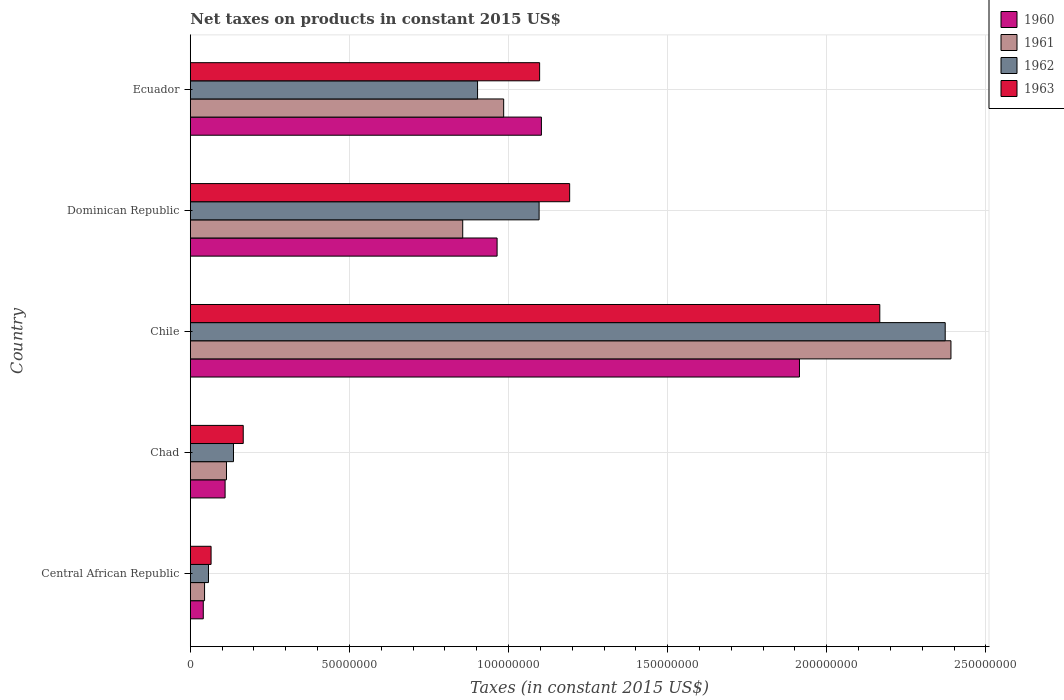How many groups of bars are there?
Provide a short and direct response. 5. How many bars are there on the 4th tick from the top?
Your answer should be compact. 4. How many bars are there on the 3rd tick from the bottom?
Keep it short and to the point. 4. What is the label of the 2nd group of bars from the top?
Provide a short and direct response. Dominican Republic. What is the net taxes on products in 1963 in Central African Republic?
Keep it short and to the point. 6.53e+06. Across all countries, what is the maximum net taxes on products in 1962?
Provide a short and direct response. 2.37e+08. Across all countries, what is the minimum net taxes on products in 1963?
Provide a short and direct response. 6.53e+06. In which country was the net taxes on products in 1962 minimum?
Your response must be concise. Central African Republic. What is the total net taxes on products in 1961 in the graph?
Offer a very short reply. 4.39e+08. What is the difference between the net taxes on products in 1962 in Central African Republic and that in Ecuador?
Make the answer very short. -8.45e+07. What is the difference between the net taxes on products in 1963 in Dominican Republic and the net taxes on products in 1961 in Chile?
Keep it short and to the point. -1.20e+08. What is the average net taxes on products in 1961 per country?
Ensure brevity in your answer.  8.78e+07. What is the difference between the net taxes on products in 1961 and net taxes on products in 1962 in Chile?
Provide a short and direct response. 1.81e+06. What is the ratio of the net taxes on products in 1960 in Chad to that in Dominican Republic?
Offer a terse response. 0.11. What is the difference between the highest and the second highest net taxes on products in 1961?
Give a very brief answer. 1.41e+08. What is the difference between the highest and the lowest net taxes on products in 1963?
Ensure brevity in your answer.  2.10e+08. In how many countries, is the net taxes on products in 1961 greater than the average net taxes on products in 1961 taken over all countries?
Your response must be concise. 2. Is the sum of the net taxes on products in 1962 in Chad and Dominican Republic greater than the maximum net taxes on products in 1963 across all countries?
Your answer should be compact. No. Is it the case that in every country, the sum of the net taxes on products in 1963 and net taxes on products in 1961 is greater than the sum of net taxes on products in 1960 and net taxes on products in 1962?
Make the answer very short. No. What does the 3rd bar from the bottom in Chile represents?
Your response must be concise. 1962. How many bars are there?
Your answer should be very brief. 20. How many countries are there in the graph?
Ensure brevity in your answer.  5. Does the graph contain any zero values?
Give a very brief answer. No. Does the graph contain grids?
Provide a succinct answer. Yes. Where does the legend appear in the graph?
Your response must be concise. Top right. How many legend labels are there?
Make the answer very short. 4. How are the legend labels stacked?
Your answer should be very brief. Vertical. What is the title of the graph?
Keep it short and to the point. Net taxes on products in constant 2015 US$. What is the label or title of the X-axis?
Provide a succinct answer. Taxes (in constant 2015 US$). What is the Taxes (in constant 2015 US$) in 1960 in Central African Republic?
Provide a short and direct response. 4.08e+06. What is the Taxes (in constant 2015 US$) in 1961 in Central African Republic?
Provide a short and direct response. 4.49e+06. What is the Taxes (in constant 2015 US$) of 1962 in Central African Republic?
Provide a succinct answer. 5.71e+06. What is the Taxes (in constant 2015 US$) of 1963 in Central African Republic?
Provide a short and direct response. 6.53e+06. What is the Taxes (in constant 2015 US$) of 1960 in Chad?
Your response must be concise. 1.09e+07. What is the Taxes (in constant 2015 US$) in 1961 in Chad?
Your answer should be very brief. 1.14e+07. What is the Taxes (in constant 2015 US$) of 1962 in Chad?
Make the answer very short. 1.36e+07. What is the Taxes (in constant 2015 US$) of 1963 in Chad?
Give a very brief answer. 1.66e+07. What is the Taxes (in constant 2015 US$) of 1960 in Chile?
Ensure brevity in your answer.  1.91e+08. What is the Taxes (in constant 2015 US$) of 1961 in Chile?
Make the answer very short. 2.39e+08. What is the Taxes (in constant 2015 US$) of 1962 in Chile?
Make the answer very short. 2.37e+08. What is the Taxes (in constant 2015 US$) in 1963 in Chile?
Your answer should be compact. 2.17e+08. What is the Taxes (in constant 2015 US$) of 1960 in Dominican Republic?
Give a very brief answer. 9.64e+07. What is the Taxes (in constant 2015 US$) of 1961 in Dominican Republic?
Your answer should be very brief. 8.56e+07. What is the Taxes (in constant 2015 US$) in 1962 in Dominican Republic?
Ensure brevity in your answer.  1.10e+08. What is the Taxes (in constant 2015 US$) of 1963 in Dominican Republic?
Offer a very short reply. 1.19e+08. What is the Taxes (in constant 2015 US$) of 1960 in Ecuador?
Your answer should be very brief. 1.10e+08. What is the Taxes (in constant 2015 US$) of 1961 in Ecuador?
Offer a very short reply. 9.85e+07. What is the Taxes (in constant 2015 US$) of 1962 in Ecuador?
Give a very brief answer. 9.03e+07. What is the Taxes (in constant 2015 US$) of 1963 in Ecuador?
Provide a succinct answer. 1.10e+08. Across all countries, what is the maximum Taxes (in constant 2015 US$) in 1960?
Keep it short and to the point. 1.91e+08. Across all countries, what is the maximum Taxes (in constant 2015 US$) in 1961?
Provide a short and direct response. 2.39e+08. Across all countries, what is the maximum Taxes (in constant 2015 US$) of 1962?
Make the answer very short. 2.37e+08. Across all countries, what is the maximum Taxes (in constant 2015 US$) of 1963?
Your response must be concise. 2.17e+08. Across all countries, what is the minimum Taxes (in constant 2015 US$) of 1960?
Provide a succinct answer. 4.08e+06. Across all countries, what is the minimum Taxes (in constant 2015 US$) in 1961?
Offer a terse response. 4.49e+06. Across all countries, what is the minimum Taxes (in constant 2015 US$) of 1962?
Offer a terse response. 5.71e+06. Across all countries, what is the minimum Taxes (in constant 2015 US$) of 1963?
Offer a very short reply. 6.53e+06. What is the total Taxes (in constant 2015 US$) of 1960 in the graph?
Make the answer very short. 4.13e+08. What is the total Taxes (in constant 2015 US$) in 1961 in the graph?
Offer a very short reply. 4.39e+08. What is the total Taxes (in constant 2015 US$) of 1962 in the graph?
Provide a succinct answer. 4.56e+08. What is the total Taxes (in constant 2015 US$) of 1963 in the graph?
Your response must be concise. 4.69e+08. What is the difference between the Taxes (in constant 2015 US$) in 1960 in Central African Republic and that in Chad?
Offer a very short reply. -6.86e+06. What is the difference between the Taxes (in constant 2015 US$) of 1961 in Central African Republic and that in Chad?
Offer a very short reply. -6.88e+06. What is the difference between the Taxes (in constant 2015 US$) of 1962 in Central African Republic and that in Chad?
Keep it short and to the point. -7.86e+06. What is the difference between the Taxes (in constant 2015 US$) of 1963 in Central African Republic and that in Chad?
Offer a very short reply. -1.01e+07. What is the difference between the Taxes (in constant 2015 US$) in 1960 in Central African Republic and that in Chile?
Your answer should be very brief. -1.87e+08. What is the difference between the Taxes (in constant 2015 US$) of 1961 in Central African Republic and that in Chile?
Give a very brief answer. -2.35e+08. What is the difference between the Taxes (in constant 2015 US$) in 1962 in Central African Republic and that in Chile?
Your answer should be very brief. -2.31e+08. What is the difference between the Taxes (in constant 2015 US$) of 1963 in Central African Republic and that in Chile?
Offer a terse response. -2.10e+08. What is the difference between the Taxes (in constant 2015 US$) of 1960 in Central African Republic and that in Dominican Republic?
Keep it short and to the point. -9.23e+07. What is the difference between the Taxes (in constant 2015 US$) in 1961 in Central African Republic and that in Dominican Republic?
Offer a very short reply. -8.11e+07. What is the difference between the Taxes (in constant 2015 US$) in 1962 in Central African Republic and that in Dominican Republic?
Provide a short and direct response. -1.04e+08. What is the difference between the Taxes (in constant 2015 US$) in 1963 in Central African Republic and that in Dominican Republic?
Provide a succinct answer. -1.13e+08. What is the difference between the Taxes (in constant 2015 US$) of 1960 in Central African Republic and that in Ecuador?
Provide a short and direct response. -1.06e+08. What is the difference between the Taxes (in constant 2015 US$) of 1961 in Central African Republic and that in Ecuador?
Make the answer very short. -9.40e+07. What is the difference between the Taxes (in constant 2015 US$) in 1962 in Central African Republic and that in Ecuador?
Your answer should be very brief. -8.45e+07. What is the difference between the Taxes (in constant 2015 US$) in 1963 in Central African Republic and that in Ecuador?
Provide a succinct answer. -1.03e+08. What is the difference between the Taxes (in constant 2015 US$) in 1960 in Chad and that in Chile?
Your answer should be compact. -1.80e+08. What is the difference between the Taxes (in constant 2015 US$) of 1961 in Chad and that in Chile?
Offer a terse response. -2.28e+08. What is the difference between the Taxes (in constant 2015 US$) in 1962 in Chad and that in Chile?
Your answer should be very brief. -2.24e+08. What is the difference between the Taxes (in constant 2015 US$) of 1963 in Chad and that in Chile?
Your answer should be compact. -2.00e+08. What is the difference between the Taxes (in constant 2015 US$) of 1960 in Chad and that in Dominican Republic?
Ensure brevity in your answer.  -8.55e+07. What is the difference between the Taxes (in constant 2015 US$) in 1961 in Chad and that in Dominican Republic?
Ensure brevity in your answer.  -7.42e+07. What is the difference between the Taxes (in constant 2015 US$) in 1962 in Chad and that in Dominican Republic?
Your response must be concise. -9.60e+07. What is the difference between the Taxes (in constant 2015 US$) in 1963 in Chad and that in Dominican Republic?
Make the answer very short. -1.03e+08. What is the difference between the Taxes (in constant 2015 US$) in 1960 in Chad and that in Ecuador?
Provide a short and direct response. -9.94e+07. What is the difference between the Taxes (in constant 2015 US$) of 1961 in Chad and that in Ecuador?
Make the answer very short. -8.71e+07. What is the difference between the Taxes (in constant 2015 US$) of 1962 in Chad and that in Ecuador?
Provide a short and direct response. -7.67e+07. What is the difference between the Taxes (in constant 2015 US$) in 1963 in Chad and that in Ecuador?
Make the answer very short. -9.31e+07. What is the difference between the Taxes (in constant 2015 US$) of 1960 in Chile and that in Dominican Republic?
Your answer should be very brief. 9.50e+07. What is the difference between the Taxes (in constant 2015 US$) of 1961 in Chile and that in Dominican Republic?
Make the answer very short. 1.53e+08. What is the difference between the Taxes (in constant 2015 US$) of 1962 in Chile and that in Dominican Republic?
Provide a short and direct response. 1.28e+08. What is the difference between the Taxes (in constant 2015 US$) in 1963 in Chile and that in Dominican Republic?
Offer a terse response. 9.74e+07. What is the difference between the Taxes (in constant 2015 US$) in 1960 in Chile and that in Ecuador?
Your answer should be very brief. 8.11e+07. What is the difference between the Taxes (in constant 2015 US$) of 1961 in Chile and that in Ecuador?
Offer a terse response. 1.41e+08. What is the difference between the Taxes (in constant 2015 US$) of 1962 in Chile and that in Ecuador?
Provide a short and direct response. 1.47e+08. What is the difference between the Taxes (in constant 2015 US$) of 1963 in Chile and that in Ecuador?
Your answer should be very brief. 1.07e+08. What is the difference between the Taxes (in constant 2015 US$) in 1960 in Dominican Republic and that in Ecuador?
Provide a succinct answer. -1.39e+07. What is the difference between the Taxes (in constant 2015 US$) in 1961 in Dominican Republic and that in Ecuador?
Offer a terse response. -1.29e+07. What is the difference between the Taxes (in constant 2015 US$) of 1962 in Dominican Republic and that in Ecuador?
Make the answer very short. 1.93e+07. What is the difference between the Taxes (in constant 2015 US$) in 1963 in Dominican Republic and that in Ecuador?
Keep it short and to the point. 9.44e+06. What is the difference between the Taxes (in constant 2015 US$) in 1960 in Central African Republic and the Taxes (in constant 2015 US$) in 1961 in Chad?
Provide a succinct answer. -7.29e+06. What is the difference between the Taxes (in constant 2015 US$) in 1960 in Central African Republic and the Taxes (in constant 2015 US$) in 1962 in Chad?
Provide a succinct answer. -9.49e+06. What is the difference between the Taxes (in constant 2015 US$) in 1960 in Central African Republic and the Taxes (in constant 2015 US$) in 1963 in Chad?
Provide a succinct answer. -1.26e+07. What is the difference between the Taxes (in constant 2015 US$) in 1961 in Central African Republic and the Taxes (in constant 2015 US$) in 1962 in Chad?
Provide a succinct answer. -9.08e+06. What is the difference between the Taxes (in constant 2015 US$) in 1961 in Central African Republic and the Taxes (in constant 2015 US$) in 1963 in Chad?
Provide a short and direct response. -1.21e+07. What is the difference between the Taxes (in constant 2015 US$) in 1962 in Central African Republic and the Taxes (in constant 2015 US$) in 1963 in Chad?
Offer a very short reply. -1.09e+07. What is the difference between the Taxes (in constant 2015 US$) of 1960 in Central African Republic and the Taxes (in constant 2015 US$) of 1961 in Chile?
Your answer should be compact. -2.35e+08. What is the difference between the Taxes (in constant 2015 US$) of 1960 in Central African Republic and the Taxes (in constant 2015 US$) of 1962 in Chile?
Your answer should be compact. -2.33e+08. What is the difference between the Taxes (in constant 2015 US$) in 1960 in Central African Republic and the Taxes (in constant 2015 US$) in 1963 in Chile?
Ensure brevity in your answer.  -2.13e+08. What is the difference between the Taxes (in constant 2015 US$) in 1961 in Central African Republic and the Taxes (in constant 2015 US$) in 1962 in Chile?
Your answer should be compact. -2.33e+08. What is the difference between the Taxes (in constant 2015 US$) of 1961 in Central African Republic and the Taxes (in constant 2015 US$) of 1963 in Chile?
Your response must be concise. -2.12e+08. What is the difference between the Taxes (in constant 2015 US$) in 1962 in Central African Republic and the Taxes (in constant 2015 US$) in 1963 in Chile?
Your response must be concise. -2.11e+08. What is the difference between the Taxes (in constant 2015 US$) in 1960 in Central African Republic and the Taxes (in constant 2015 US$) in 1961 in Dominican Republic?
Offer a terse response. -8.15e+07. What is the difference between the Taxes (in constant 2015 US$) in 1960 in Central African Republic and the Taxes (in constant 2015 US$) in 1962 in Dominican Republic?
Offer a very short reply. -1.06e+08. What is the difference between the Taxes (in constant 2015 US$) in 1960 in Central African Republic and the Taxes (in constant 2015 US$) in 1963 in Dominican Republic?
Provide a succinct answer. -1.15e+08. What is the difference between the Taxes (in constant 2015 US$) of 1961 in Central African Republic and the Taxes (in constant 2015 US$) of 1962 in Dominican Republic?
Your response must be concise. -1.05e+08. What is the difference between the Taxes (in constant 2015 US$) of 1961 in Central African Republic and the Taxes (in constant 2015 US$) of 1963 in Dominican Republic?
Ensure brevity in your answer.  -1.15e+08. What is the difference between the Taxes (in constant 2015 US$) in 1962 in Central African Republic and the Taxes (in constant 2015 US$) in 1963 in Dominican Republic?
Make the answer very short. -1.13e+08. What is the difference between the Taxes (in constant 2015 US$) of 1960 in Central African Republic and the Taxes (in constant 2015 US$) of 1961 in Ecuador?
Make the answer very short. -9.44e+07. What is the difference between the Taxes (in constant 2015 US$) in 1960 in Central African Republic and the Taxes (in constant 2015 US$) in 1962 in Ecuador?
Provide a succinct answer. -8.62e+07. What is the difference between the Taxes (in constant 2015 US$) of 1960 in Central African Republic and the Taxes (in constant 2015 US$) of 1963 in Ecuador?
Give a very brief answer. -1.06e+08. What is the difference between the Taxes (in constant 2015 US$) of 1961 in Central African Republic and the Taxes (in constant 2015 US$) of 1962 in Ecuador?
Offer a very short reply. -8.58e+07. What is the difference between the Taxes (in constant 2015 US$) in 1961 in Central African Republic and the Taxes (in constant 2015 US$) in 1963 in Ecuador?
Give a very brief answer. -1.05e+08. What is the difference between the Taxes (in constant 2015 US$) in 1962 in Central African Republic and the Taxes (in constant 2015 US$) in 1963 in Ecuador?
Your response must be concise. -1.04e+08. What is the difference between the Taxes (in constant 2015 US$) of 1960 in Chad and the Taxes (in constant 2015 US$) of 1961 in Chile?
Ensure brevity in your answer.  -2.28e+08. What is the difference between the Taxes (in constant 2015 US$) of 1960 in Chad and the Taxes (in constant 2015 US$) of 1962 in Chile?
Keep it short and to the point. -2.26e+08. What is the difference between the Taxes (in constant 2015 US$) in 1960 in Chad and the Taxes (in constant 2015 US$) in 1963 in Chile?
Your response must be concise. -2.06e+08. What is the difference between the Taxes (in constant 2015 US$) of 1961 in Chad and the Taxes (in constant 2015 US$) of 1962 in Chile?
Your answer should be very brief. -2.26e+08. What is the difference between the Taxes (in constant 2015 US$) of 1961 in Chad and the Taxes (in constant 2015 US$) of 1963 in Chile?
Offer a terse response. -2.05e+08. What is the difference between the Taxes (in constant 2015 US$) of 1962 in Chad and the Taxes (in constant 2015 US$) of 1963 in Chile?
Your response must be concise. -2.03e+08. What is the difference between the Taxes (in constant 2015 US$) in 1960 in Chad and the Taxes (in constant 2015 US$) in 1961 in Dominican Republic?
Offer a terse response. -7.47e+07. What is the difference between the Taxes (in constant 2015 US$) of 1960 in Chad and the Taxes (in constant 2015 US$) of 1962 in Dominican Republic?
Keep it short and to the point. -9.87e+07. What is the difference between the Taxes (in constant 2015 US$) in 1960 in Chad and the Taxes (in constant 2015 US$) in 1963 in Dominican Republic?
Give a very brief answer. -1.08e+08. What is the difference between the Taxes (in constant 2015 US$) of 1961 in Chad and the Taxes (in constant 2015 US$) of 1962 in Dominican Republic?
Make the answer very short. -9.82e+07. What is the difference between the Taxes (in constant 2015 US$) of 1961 in Chad and the Taxes (in constant 2015 US$) of 1963 in Dominican Republic?
Your response must be concise. -1.08e+08. What is the difference between the Taxes (in constant 2015 US$) of 1962 in Chad and the Taxes (in constant 2015 US$) of 1963 in Dominican Republic?
Make the answer very short. -1.06e+08. What is the difference between the Taxes (in constant 2015 US$) of 1960 in Chad and the Taxes (in constant 2015 US$) of 1961 in Ecuador?
Offer a very short reply. -8.75e+07. What is the difference between the Taxes (in constant 2015 US$) in 1960 in Chad and the Taxes (in constant 2015 US$) in 1962 in Ecuador?
Your answer should be very brief. -7.93e+07. What is the difference between the Taxes (in constant 2015 US$) in 1960 in Chad and the Taxes (in constant 2015 US$) in 1963 in Ecuador?
Keep it short and to the point. -9.88e+07. What is the difference between the Taxes (in constant 2015 US$) of 1961 in Chad and the Taxes (in constant 2015 US$) of 1962 in Ecuador?
Make the answer very short. -7.89e+07. What is the difference between the Taxes (in constant 2015 US$) in 1961 in Chad and the Taxes (in constant 2015 US$) in 1963 in Ecuador?
Your response must be concise. -9.84e+07. What is the difference between the Taxes (in constant 2015 US$) in 1962 in Chad and the Taxes (in constant 2015 US$) in 1963 in Ecuador?
Keep it short and to the point. -9.62e+07. What is the difference between the Taxes (in constant 2015 US$) of 1960 in Chile and the Taxes (in constant 2015 US$) of 1961 in Dominican Republic?
Your response must be concise. 1.06e+08. What is the difference between the Taxes (in constant 2015 US$) in 1960 in Chile and the Taxes (in constant 2015 US$) in 1962 in Dominican Republic?
Offer a terse response. 8.18e+07. What is the difference between the Taxes (in constant 2015 US$) of 1960 in Chile and the Taxes (in constant 2015 US$) of 1963 in Dominican Republic?
Keep it short and to the point. 7.22e+07. What is the difference between the Taxes (in constant 2015 US$) in 1961 in Chile and the Taxes (in constant 2015 US$) in 1962 in Dominican Republic?
Ensure brevity in your answer.  1.29e+08. What is the difference between the Taxes (in constant 2015 US$) in 1961 in Chile and the Taxes (in constant 2015 US$) in 1963 in Dominican Republic?
Provide a short and direct response. 1.20e+08. What is the difference between the Taxes (in constant 2015 US$) in 1962 in Chile and the Taxes (in constant 2015 US$) in 1963 in Dominican Republic?
Offer a terse response. 1.18e+08. What is the difference between the Taxes (in constant 2015 US$) of 1960 in Chile and the Taxes (in constant 2015 US$) of 1961 in Ecuador?
Offer a very short reply. 9.29e+07. What is the difference between the Taxes (in constant 2015 US$) in 1960 in Chile and the Taxes (in constant 2015 US$) in 1962 in Ecuador?
Your response must be concise. 1.01e+08. What is the difference between the Taxes (in constant 2015 US$) of 1960 in Chile and the Taxes (in constant 2015 US$) of 1963 in Ecuador?
Offer a terse response. 8.16e+07. What is the difference between the Taxes (in constant 2015 US$) in 1961 in Chile and the Taxes (in constant 2015 US$) in 1962 in Ecuador?
Your response must be concise. 1.49e+08. What is the difference between the Taxes (in constant 2015 US$) in 1961 in Chile and the Taxes (in constant 2015 US$) in 1963 in Ecuador?
Offer a terse response. 1.29e+08. What is the difference between the Taxes (in constant 2015 US$) of 1962 in Chile and the Taxes (in constant 2015 US$) of 1963 in Ecuador?
Offer a terse response. 1.27e+08. What is the difference between the Taxes (in constant 2015 US$) of 1960 in Dominican Republic and the Taxes (in constant 2015 US$) of 1961 in Ecuador?
Give a very brief answer. -2.07e+06. What is the difference between the Taxes (in constant 2015 US$) of 1960 in Dominican Republic and the Taxes (in constant 2015 US$) of 1962 in Ecuador?
Offer a very short reply. 6.14e+06. What is the difference between the Taxes (in constant 2015 US$) of 1960 in Dominican Republic and the Taxes (in constant 2015 US$) of 1963 in Ecuador?
Your response must be concise. -1.34e+07. What is the difference between the Taxes (in constant 2015 US$) of 1961 in Dominican Republic and the Taxes (in constant 2015 US$) of 1962 in Ecuador?
Provide a succinct answer. -4.66e+06. What is the difference between the Taxes (in constant 2015 US$) in 1961 in Dominican Republic and the Taxes (in constant 2015 US$) in 1963 in Ecuador?
Your response must be concise. -2.42e+07. What is the difference between the Taxes (in constant 2015 US$) of 1962 in Dominican Republic and the Taxes (in constant 2015 US$) of 1963 in Ecuador?
Ensure brevity in your answer.  -1.64e+05. What is the average Taxes (in constant 2015 US$) in 1960 per country?
Your response must be concise. 8.26e+07. What is the average Taxes (in constant 2015 US$) in 1961 per country?
Give a very brief answer. 8.78e+07. What is the average Taxes (in constant 2015 US$) in 1962 per country?
Provide a succinct answer. 9.13e+07. What is the average Taxes (in constant 2015 US$) in 1963 per country?
Make the answer very short. 9.38e+07. What is the difference between the Taxes (in constant 2015 US$) in 1960 and Taxes (in constant 2015 US$) in 1961 in Central African Republic?
Make the answer very short. -4.07e+05. What is the difference between the Taxes (in constant 2015 US$) of 1960 and Taxes (in constant 2015 US$) of 1962 in Central African Republic?
Give a very brief answer. -1.64e+06. What is the difference between the Taxes (in constant 2015 US$) of 1960 and Taxes (in constant 2015 US$) of 1963 in Central African Republic?
Keep it short and to the point. -2.45e+06. What is the difference between the Taxes (in constant 2015 US$) in 1961 and Taxes (in constant 2015 US$) in 1962 in Central African Republic?
Make the answer very short. -1.23e+06. What is the difference between the Taxes (in constant 2015 US$) in 1961 and Taxes (in constant 2015 US$) in 1963 in Central African Republic?
Ensure brevity in your answer.  -2.05e+06. What is the difference between the Taxes (in constant 2015 US$) of 1962 and Taxes (in constant 2015 US$) of 1963 in Central African Republic?
Keep it short and to the point. -8.16e+05. What is the difference between the Taxes (in constant 2015 US$) in 1960 and Taxes (in constant 2015 US$) in 1961 in Chad?
Your response must be concise. -4.34e+05. What is the difference between the Taxes (in constant 2015 US$) of 1960 and Taxes (in constant 2015 US$) of 1962 in Chad?
Make the answer very short. -2.63e+06. What is the difference between the Taxes (in constant 2015 US$) of 1960 and Taxes (in constant 2015 US$) of 1963 in Chad?
Provide a succinct answer. -5.70e+06. What is the difference between the Taxes (in constant 2015 US$) of 1961 and Taxes (in constant 2015 US$) of 1962 in Chad?
Offer a very short reply. -2.20e+06. What is the difference between the Taxes (in constant 2015 US$) of 1961 and Taxes (in constant 2015 US$) of 1963 in Chad?
Your answer should be compact. -5.26e+06. What is the difference between the Taxes (in constant 2015 US$) of 1962 and Taxes (in constant 2015 US$) of 1963 in Chad?
Keep it short and to the point. -3.06e+06. What is the difference between the Taxes (in constant 2015 US$) in 1960 and Taxes (in constant 2015 US$) in 1961 in Chile?
Keep it short and to the point. -4.76e+07. What is the difference between the Taxes (in constant 2015 US$) in 1960 and Taxes (in constant 2015 US$) in 1962 in Chile?
Make the answer very short. -4.58e+07. What is the difference between the Taxes (in constant 2015 US$) in 1960 and Taxes (in constant 2015 US$) in 1963 in Chile?
Your answer should be very brief. -2.52e+07. What is the difference between the Taxes (in constant 2015 US$) of 1961 and Taxes (in constant 2015 US$) of 1962 in Chile?
Offer a terse response. 1.81e+06. What is the difference between the Taxes (in constant 2015 US$) of 1961 and Taxes (in constant 2015 US$) of 1963 in Chile?
Your answer should be compact. 2.24e+07. What is the difference between the Taxes (in constant 2015 US$) in 1962 and Taxes (in constant 2015 US$) in 1963 in Chile?
Ensure brevity in your answer.  2.06e+07. What is the difference between the Taxes (in constant 2015 US$) of 1960 and Taxes (in constant 2015 US$) of 1961 in Dominican Republic?
Provide a short and direct response. 1.08e+07. What is the difference between the Taxes (in constant 2015 US$) of 1960 and Taxes (in constant 2015 US$) of 1962 in Dominican Republic?
Offer a very short reply. -1.32e+07. What is the difference between the Taxes (in constant 2015 US$) of 1960 and Taxes (in constant 2015 US$) of 1963 in Dominican Republic?
Offer a very short reply. -2.28e+07. What is the difference between the Taxes (in constant 2015 US$) of 1961 and Taxes (in constant 2015 US$) of 1962 in Dominican Republic?
Offer a very short reply. -2.40e+07. What is the difference between the Taxes (in constant 2015 US$) of 1961 and Taxes (in constant 2015 US$) of 1963 in Dominican Republic?
Your answer should be compact. -3.36e+07. What is the difference between the Taxes (in constant 2015 US$) of 1962 and Taxes (in constant 2015 US$) of 1963 in Dominican Republic?
Provide a short and direct response. -9.60e+06. What is the difference between the Taxes (in constant 2015 US$) in 1960 and Taxes (in constant 2015 US$) in 1961 in Ecuador?
Offer a very short reply. 1.19e+07. What is the difference between the Taxes (in constant 2015 US$) in 1960 and Taxes (in constant 2015 US$) in 1962 in Ecuador?
Your response must be concise. 2.01e+07. What is the difference between the Taxes (in constant 2015 US$) of 1960 and Taxes (in constant 2015 US$) of 1963 in Ecuador?
Your answer should be compact. 5.57e+05. What is the difference between the Taxes (in constant 2015 US$) in 1961 and Taxes (in constant 2015 US$) in 1962 in Ecuador?
Provide a succinct answer. 8.21e+06. What is the difference between the Taxes (in constant 2015 US$) of 1961 and Taxes (in constant 2015 US$) of 1963 in Ecuador?
Your answer should be very brief. -1.13e+07. What is the difference between the Taxes (in constant 2015 US$) in 1962 and Taxes (in constant 2015 US$) in 1963 in Ecuador?
Your response must be concise. -1.95e+07. What is the ratio of the Taxes (in constant 2015 US$) of 1960 in Central African Republic to that in Chad?
Provide a succinct answer. 0.37. What is the ratio of the Taxes (in constant 2015 US$) of 1961 in Central African Republic to that in Chad?
Offer a terse response. 0.39. What is the ratio of the Taxes (in constant 2015 US$) of 1962 in Central African Republic to that in Chad?
Make the answer very short. 0.42. What is the ratio of the Taxes (in constant 2015 US$) of 1963 in Central African Republic to that in Chad?
Your response must be concise. 0.39. What is the ratio of the Taxes (in constant 2015 US$) in 1960 in Central African Republic to that in Chile?
Offer a very short reply. 0.02. What is the ratio of the Taxes (in constant 2015 US$) in 1961 in Central African Republic to that in Chile?
Keep it short and to the point. 0.02. What is the ratio of the Taxes (in constant 2015 US$) in 1962 in Central African Republic to that in Chile?
Ensure brevity in your answer.  0.02. What is the ratio of the Taxes (in constant 2015 US$) in 1963 in Central African Republic to that in Chile?
Make the answer very short. 0.03. What is the ratio of the Taxes (in constant 2015 US$) in 1960 in Central African Republic to that in Dominican Republic?
Provide a short and direct response. 0.04. What is the ratio of the Taxes (in constant 2015 US$) in 1961 in Central African Republic to that in Dominican Republic?
Provide a succinct answer. 0.05. What is the ratio of the Taxes (in constant 2015 US$) in 1962 in Central African Republic to that in Dominican Republic?
Your response must be concise. 0.05. What is the ratio of the Taxes (in constant 2015 US$) in 1963 in Central African Republic to that in Dominican Republic?
Ensure brevity in your answer.  0.05. What is the ratio of the Taxes (in constant 2015 US$) of 1960 in Central African Republic to that in Ecuador?
Your answer should be compact. 0.04. What is the ratio of the Taxes (in constant 2015 US$) in 1961 in Central African Republic to that in Ecuador?
Offer a terse response. 0.05. What is the ratio of the Taxes (in constant 2015 US$) in 1962 in Central African Republic to that in Ecuador?
Give a very brief answer. 0.06. What is the ratio of the Taxes (in constant 2015 US$) in 1963 in Central African Republic to that in Ecuador?
Your answer should be compact. 0.06. What is the ratio of the Taxes (in constant 2015 US$) in 1960 in Chad to that in Chile?
Provide a short and direct response. 0.06. What is the ratio of the Taxes (in constant 2015 US$) in 1961 in Chad to that in Chile?
Keep it short and to the point. 0.05. What is the ratio of the Taxes (in constant 2015 US$) of 1962 in Chad to that in Chile?
Your answer should be very brief. 0.06. What is the ratio of the Taxes (in constant 2015 US$) in 1963 in Chad to that in Chile?
Keep it short and to the point. 0.08. What is the ratio of the Taxes (in constant 2015 US$) in 1960 in Chad to that in Dominican Republic?
Provide a short and direct response. 0.11. What is the ratio of the Taxes (in constant 2015 US$) of 1961 in Chad to that in Dominican Republic?
Give a very brief answer. 0.13. What is the ratio of the Taxes (in constant 2015 US$) of 1962 in Chad to that in Dominican Republic?
Give a very brief answer. 0.12. What is the ratio of the Taxes (in constant 2015 US$) in 1963 in Chad to that in Dominican Republic?
Keep it short and to the point. 0.14. What is the ratio of the Taxes (in constant 2015 US$) in 1960 in Chad to that in Ecuador?
Give a very brief answer. 0.1. What is the ratio of the Taxes (in constant 2015 US$) of 1961 in Chad to that in Ecuador?
Keep it short and to the point. 0.12. What is the ratio of the Taxes (in constant 2015 US$) of 1962 in Chad to that in Ecuador?
Your answer should be compact. 0.15. What is the ratio of the Taxes (in constant 2015 US$) of 1963 in Chad to that in Ecuador?
Ensure brevity in your answer.  0.15. What is the ratio of the Taxes (in constant 2015 US$) of 1960 in Chile to that in Dominican Republic?
Offer a terse response. 1.99. What is the ratio of the Taxes (in constant 2015 US$) of 1961 in Chile to that in Dominican Republic?
Your response must be concise. 2.79. What is the ratio of the Taxes (in constant 2015 US$) in 1962 in Chile to that in Dominican Republic?
Make the answer very short. 2.16. What is the ratio of the Taxes (in constant 2015 US$) in 1963 in Chile to that in Dominican Republic?
Make the answer very short. 1.82. What is the ratio of the Taxes (in constant 2015 US$) of 1960 in Chile to that in Ecuador?
Your answer should be compact. 1.74. What is the ratio of the Taxes (in constant 2015 US$) in 1961 in Chile to that in Ecuador?
Provide a succinct answer. 2.43. What is the ratio of the Taxes (in constant 2015 US$) in 1962 in Chile to that in Ecuador?
Your answer should be compact. 2.63. What is the ratio of the Taxes (in constant 2015 US$) of 1963 in Chile to that in Ecuador?
Give a very brief answer. 1.97. What is the ratio of the Taxes (in constant 2015 US$) in 1960 in Dominican Republic to that in Ecuador?
Offer a terse response. 0.87. What is the ratio of the Taxes (in constant 2015 US$) in 1961 in Dominican Republic to that in Ecuador?
Ensure brevity in your answer.  0.87. What is the ratio of the Taxes (in constant 2015 US$) in 1962 in Dominican Republic to that in Ecuador?
Your response must be concise. 1.21. What is the ratio of the Taxes (in constant 2015 US$) of 1963 in Dominican Republic to that in Ecuador?
Provide a short and direct response. 1.09. What is the difference between the highest and the second highest Taxes (in constant 2015 US$) in 1960?
Your answer should be compact. 8.11e+07. What is the difference between the highest and the second highest Taxes (in constant 2015 US$) of 1961?
Provide a short and direct response. 1.41e+08. What is the difference between the highest and the second highest Taxes (in constant 2015 US$) of 1962?
Provide a short and direct response. 1.28e+08. What is the difference between the highest and the second highest Taxes (in constant 2015 US$) of 1963?
Provide a short and direct response. 9.74e+07. What is the difference between the highest and the lowest Taxes (in constant 2015 US$) of 1960?
Your answer should be compact. 1.87e+08. What is the difference between the highest and the lowest Taxes (in constant 2015 US$) of 1961?
Ensure brevity in your answer.  2.35e+08. What is the difference between the highest and the lowest Taxes (in constant 2015 US$) in 1962?
Provide a succinct answer. 2.31e+08. What is the difference between the highest and the lowest Taxes (in constant 2015 US$) of 1963?
Provide a succinct answer. 2.10e+08. 